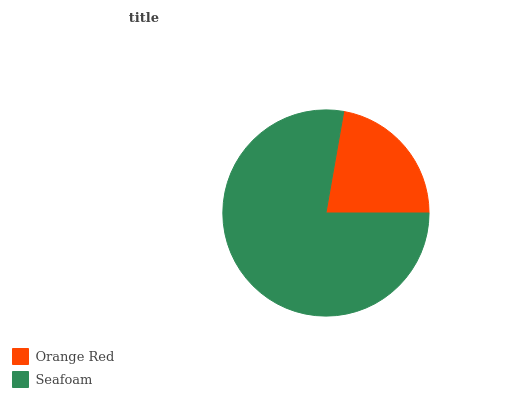Is Orange Red the minimum?
Answer yes or no. Yes. Is Seafoam the maximum?
Answer yes or no. Yes. Is Seafoam the minimum?
Answer yes or no. No. Is Seafoam greater than Orange Red?
Answer yes or no. Yes. Is Orange Red less than Seafoam?
Answer yes or no. Yes. Is Orange Red greater than Seafoam?
Answer yes or no. No. Is Seafoam less than Orange Red?
Answer yes or no. No. Is Seafoam the high median?
Answer yes or no. Yes. Is Orange Red the low median?
Answer yes or no. Yes. Is Orange Red the high median?
Answer yes or no. No. Is Seafoam the low median?
Answer yes or no. No. 